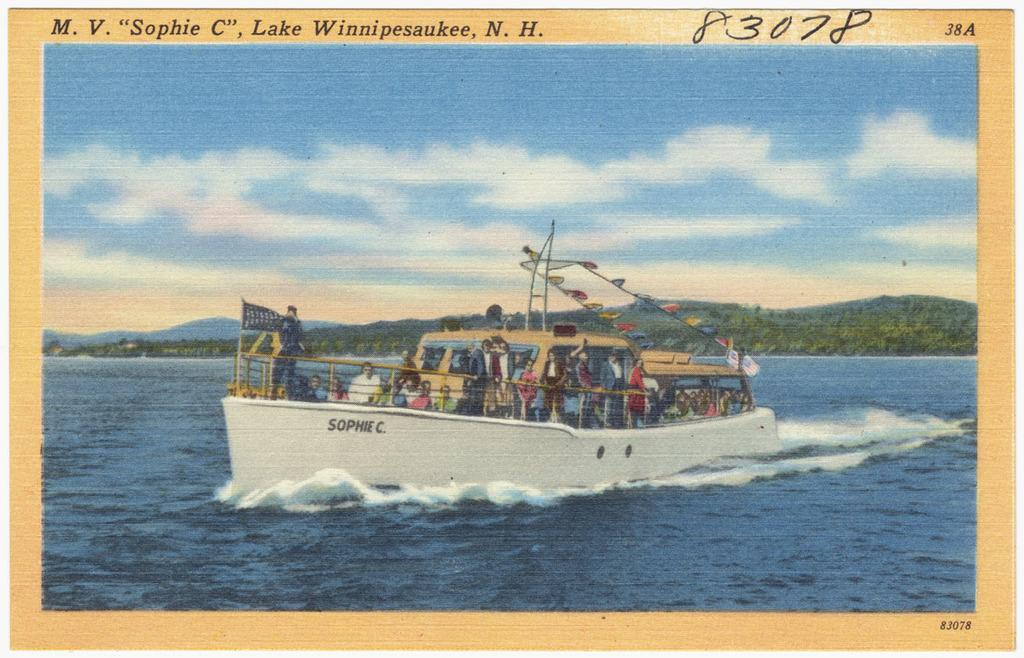<image>
Present a compact description of the photo's key features. Postcard showing a ship and the name SOPHIE C on the side. 